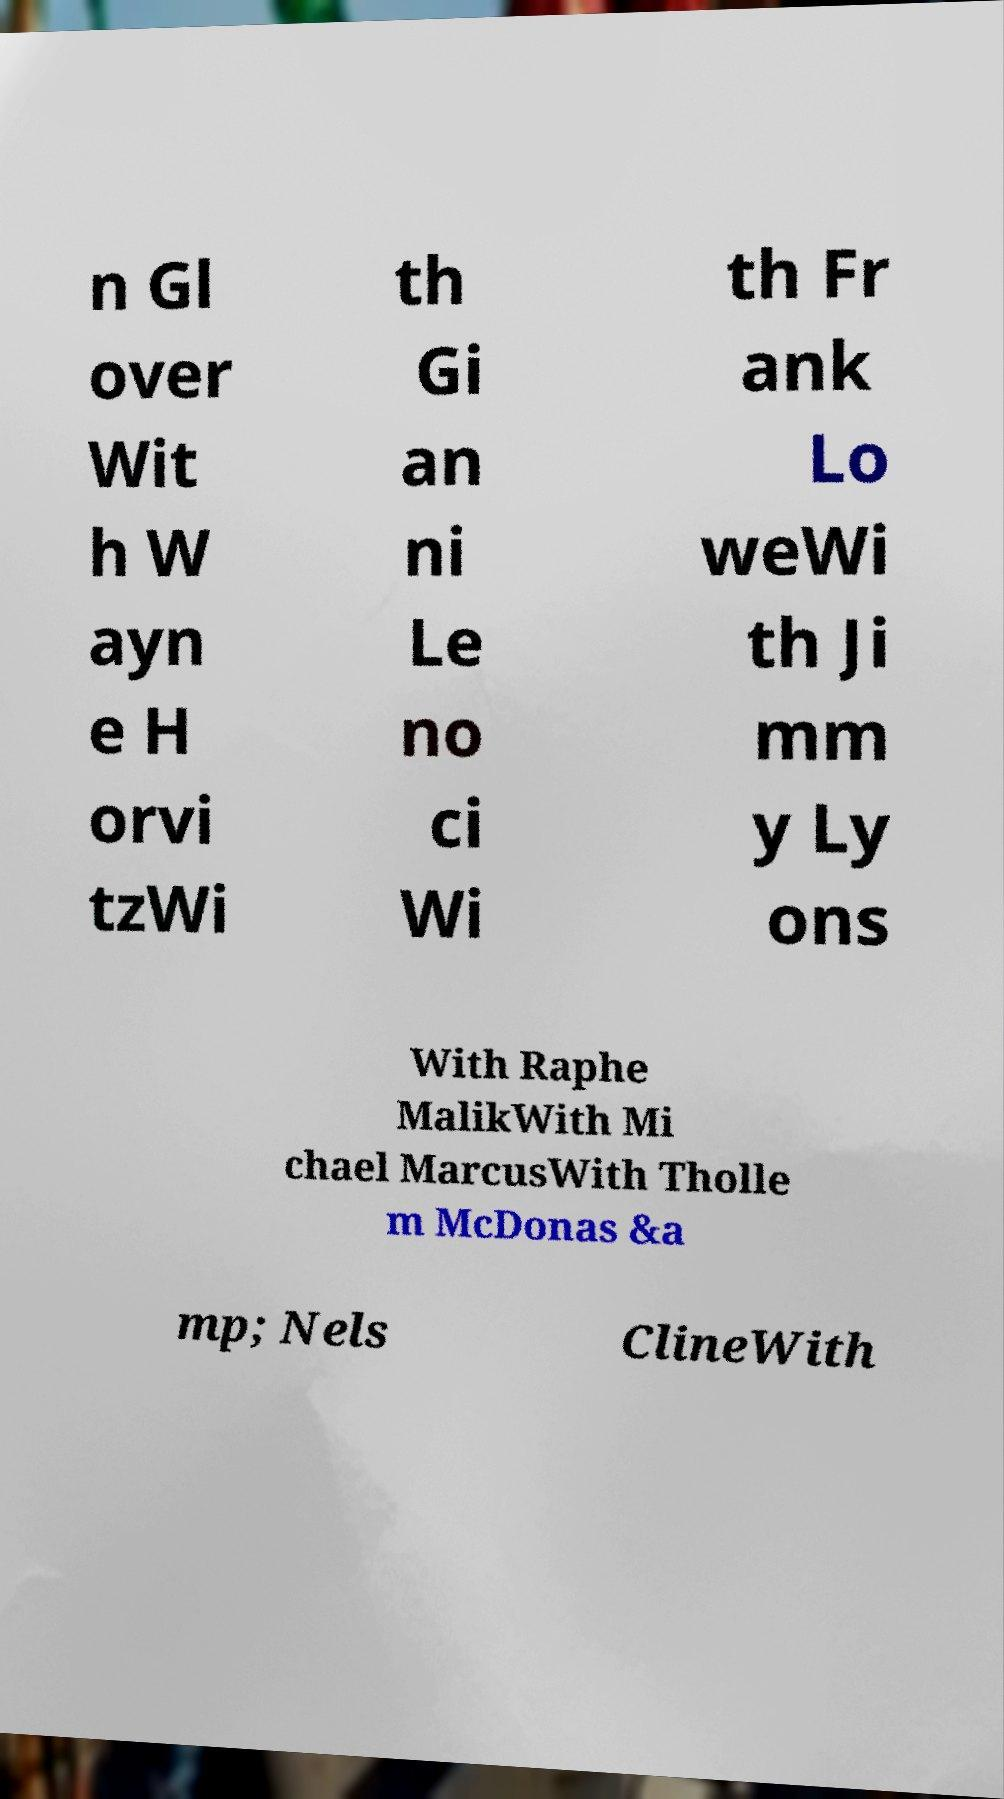Please read and relay the text visible in this image. What does it say? n Gl over Wit h W ayn e H orvi tzWi th Gi an ni Le no ci Wi th Fr ank Lo weWi th Ji mm y Ly ons With Raphe MalikWith Mi chael MarcusWith Tholle m McDonas &a mp; Nels ClineWith 